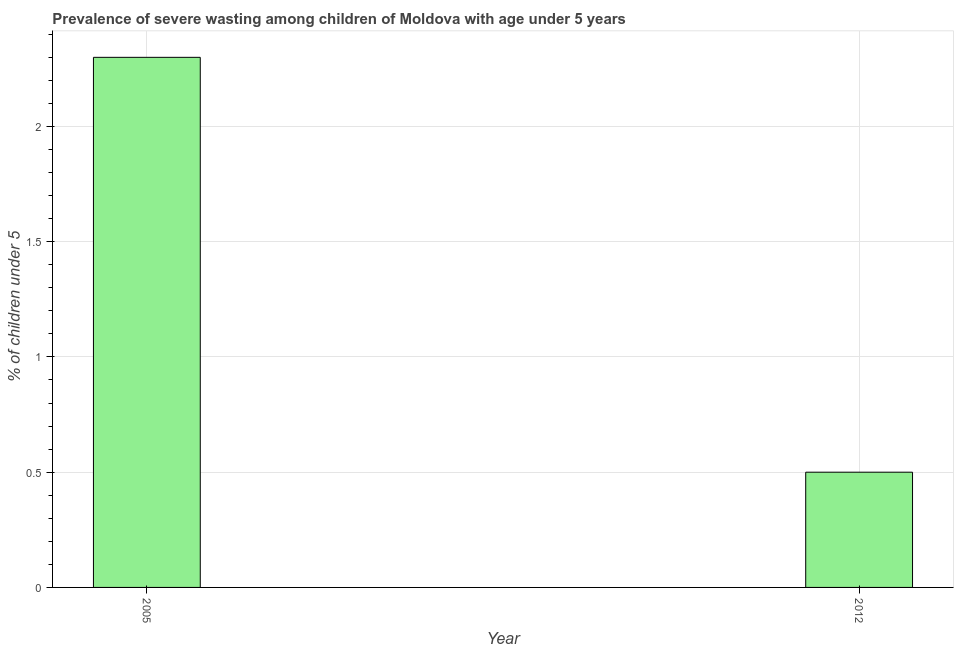Does the graph contain any zero values?
Provide a short and direct response. No. Does the graph contain grids?
Your response must be concise. Yes. What is the title of the graph?
Give a very brief answer. Prevalence of severe wasting among children of Moldova with age under 5 years. What is the label or title of the X-axis?
Provide a succinct answer. Year. What is the label or title of the Y-axis?
Give a very brief answer.  % of children under 5. What is the prevalence of severe wasting in 2012?
Keep it short and to the point. 0.5. Across all years, what is the maximum prevalence of severe wasting?
Make the answer very short. 2.3. Across all years, what is the minimum prevalence of severe wasting?
Make the answer very short. 0.5. In which year was the prevalence of severe wasting minimum?
Keep it short and to the point. 2012. What is the sum of the prevalence of severe wasting?
Your answer should be compact. 2.8. What is the difference between the prevalence of severe wasting in 2005 and 2012?
Your response must be concise. 1.8. What is the average prevalence of severe wasting per year?
Your response must be concise. 1.4. What is the median prevalence of severe wasting?
Your response must be concise. 1.4. Is the prevalence of severe wasting in 2005 less than that in 2012?
Provide a succinct answer. No. In how many years, is the prevalence of severe wasting greater than the average prevalence of severe wasting taken over all years?
Your response must be concise. 1. Are the values on the major ticks of Y-axis written in scientific E-notation?
Your answer should be compact. No. What is the  % of children under 5 in 2005?
Offer a very short reply. 2.3. What is the difference between the  % of children under 5 in 2005 and 2012?
Make the answer very short. 1.8. What is the ratio of the  % of children under 5 in 2005 to that in 2012?
Your answer should be very brief. 4.6. 